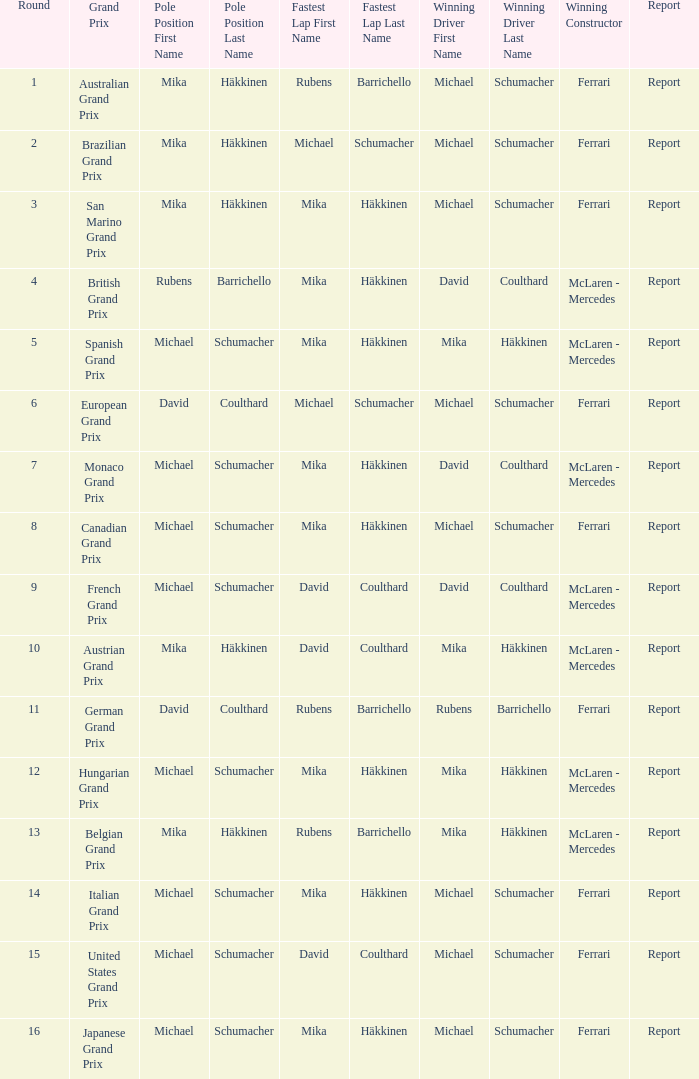What was the summary of the belgian grand prix? Report. 